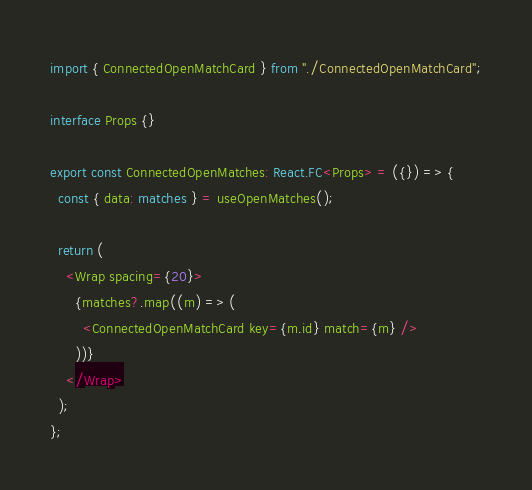<code> <loc_0><loc_0><loc_500><loc_500><_TypeScript_>import { ConnectedOpenMatchCard } from "./ConnectedOpenMatchCard";

interface Props {}

export const ConnectedOpenMatches: React.FC<Props> = ({}) => {
  const { data: matches } = useOpenMatches();

  return (
    <Wrap spacing={20}>
      {matches?.map((m) => (
        <ConnectedOpenMatchCard key={m.id} match={m} />
      ))}
    </Wrap>
  );
};
</code> 